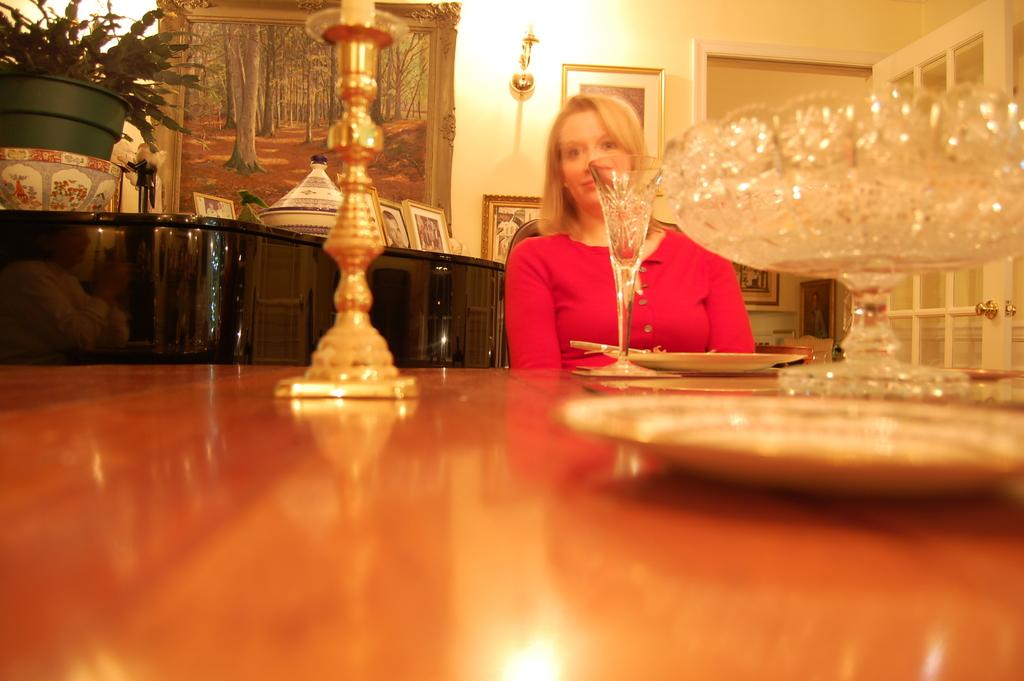What can be seen in the background of the image? There is a wall in the image. What is hanging on the wall? There is a photo frame in the image. Who is present in the image? There is a woman sitting on a chair in the image. What is in front of the woman? There is a table in front of the woman. What items are on the table? There are plates and a bowl on the table. What type of milk is being used to create the art in the image? There is no art or milk present in the image. How many sticks are visible in the image? There are no sticks visible in the image. 